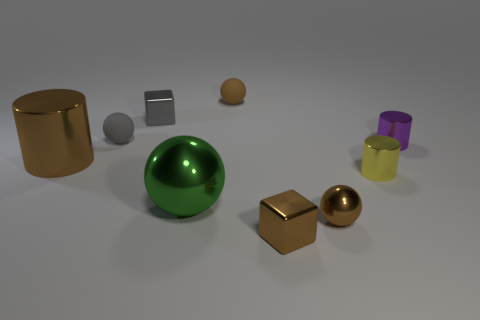Subtract all purple metal cylinders. How many cylinders are left? 2 Subtract all yellow cylinders. How many cylinders are left? 2 Add 1 tiny gray balls. How many objects exist? 10 Subtract all spheres. How many objects are left? 5 Subtract 2 cylinders. How many cylinders are left? 1 Subtract all gray balls. Subtract all red cylinders. How many balls are left? 3 Subtract all purple cylinders. How many gray blocks are left? 1 Subtract all gray rubber spheres. Subtract all tiny gray objects. How many objects are left? 6 Add 6 tiny gray objects. How many tiny gray objects are left? 8 Add 7 big metal balls. How many big metal balls exist? 8 